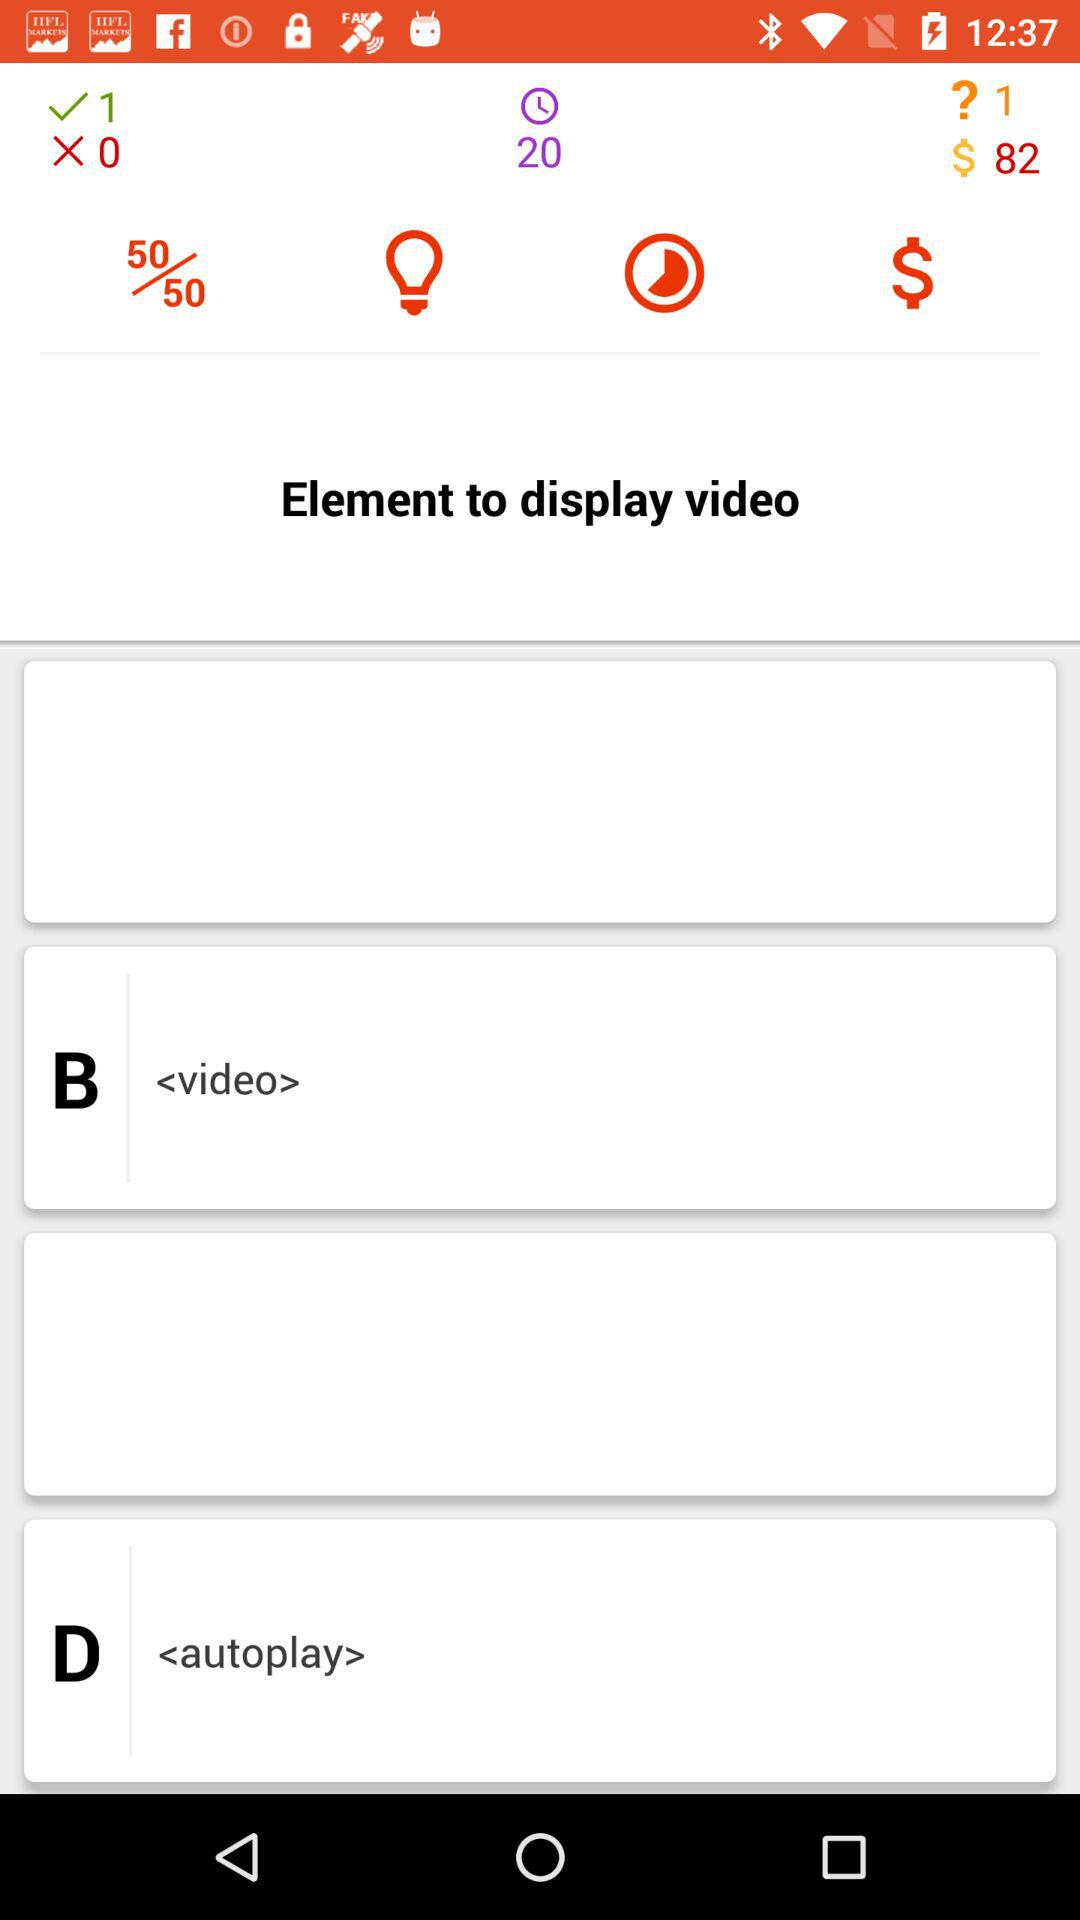What is the total number of correct questions? The total number of correct questions is 1. 